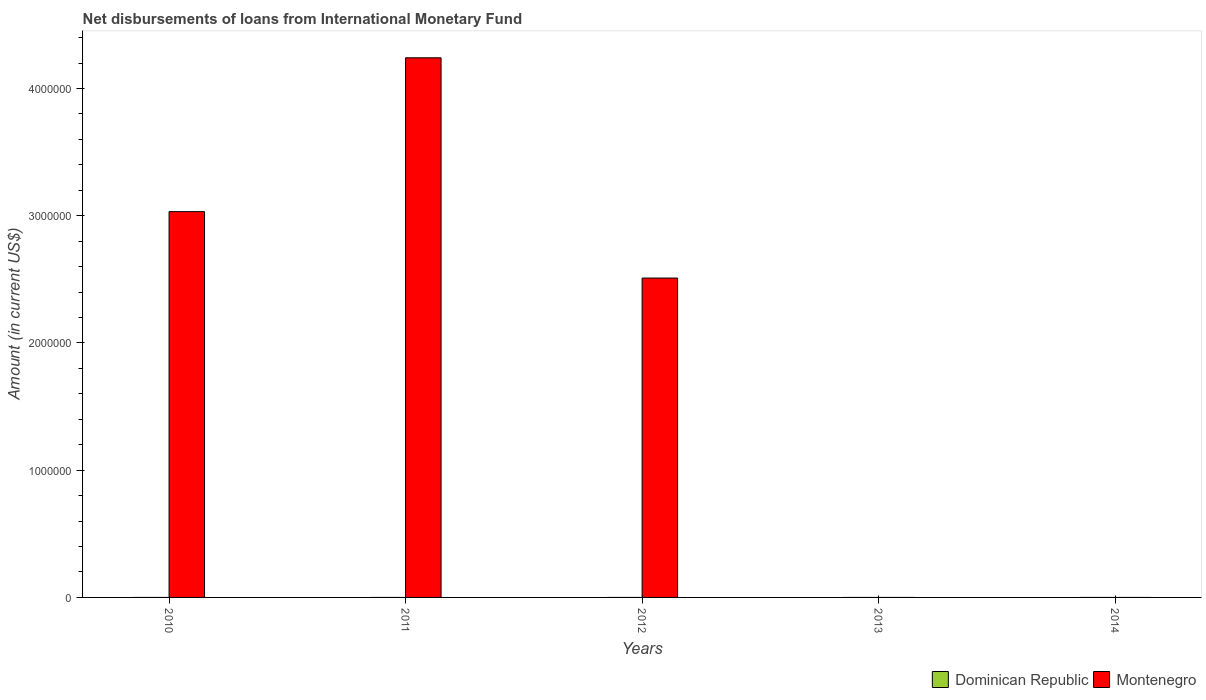Are the number of bars per tick equal to the number of legend labels?
Offer a terse response. No. Are the number of bars on each tick of the X-axis equal?
Your answer should be very brief. No. How many bars are there on the 2nd tick from the left?
Provide a succinct answer. 1. In how many cases, is the number of bars for a given year not equal to the number of legend labels?
Provide a short and direct response. 5. Across all years, what is the maximum amount of loans disbursed in Montenegro?
Make the answer very short. 4.24e+06. Across all years, what is the minimum amount of loans disbursed in Montenegro?
Ensure brevity in your answer.  0. In which year was the amount of loans disbursed in Montenegro maximum?
Your answer should be very brief. 2011. What is the total amount of loans disbursed in Montenegro in the graph?
Your answer should be compact. 9.78e+06. What is the difference between the amount of loans disbursed in Montenegro in 2010 and that in 2012?
Offer a terse response. 5.22e+05. What is the difference between the amount of loans disbursed in Montenegro in 2011 and the amount of loans disbursed in Dominican Republic in 2010?
Ensure brevity in your answer.  4.24e+06. What is the average amount of loans disbursed in Dominican Republic per year?
Make the answer very short. 0. What is the ratio of the amount of loans disbursed in Montenegro in 2010 to that in 2012?
Keep it short and to the point. 1.21. What is the difference between the highest and the second highest amount of loans disbursed in Montenegro?
Offer a terse response. 1.21e+06. What is the difference between the highest and the lowest amount of loans disbursed in Montenegro?
Your response must be concise. 4.24e+06. In how many years, is the amount of loans disbursed in Dominican Republic greater than the average amount of loans disbursed in Dominican Republic taken over all years?
Provide a succinct answer. 0. How many bars are there?
Your answer should be compact. 3. What is the difference between two consecutive major ticks on the Y-axis?
Your answer should be very brief. 1.00e+06. Are the values on the major ticks of Y-axis written in scientific E-notation?
Keep it short and to the point. No. What is the title of the graph?
Keep it short and to the point. Net disbursements of loans from International Monetary Fund. Does "West Bank and Gaza" appear as one of the legend labels in the graph?
Your answer should be very brief. No. What is the Amount (in current US$) in Dominican Republic in 2010?
Provide a succinct answer. 0. What is the Amount (in current US$) in Montenegro in 2010?
Your response must be concise. 3.03e+06. What is the Amount (in current US$) in Montenegro in 2011?
Your response must be concise. 4.24e+06. What is the Amount (in current US$) in Montenegro in 2012?
Your response must be concise. 2.51e+06. What is the Amount (in current US$) in Dominican Republic in 2013?
Your response must be concise. 0. What is the Amount (in current US$) of Montenegro in 2013?
Your answer should be compact. 0. What is the Amount (in current US$) in Dominican Republic in 2014?
Make the answer very short. 0. What is the Amount (in current US$) in Montenegro in 2014?
Your response must be concise. 0. Across all years, what is the maximum Amount (in current US$) of Montenegro?
Keep it short and to the point. 4.24e+06. What is the total Amount (in current US$) of Dominican Republic in the graph?
Your response must be concise. 0. What is the total Amount (in current US$) in Montenegro in the graph?
Offer a very short reply. 9.78e+06. What is the difference between the Amount (in current US$) of Montenegro in 2010 and that in 2011?
Make the answer very short. -1.21e+06. What is the difference between the Amount (in current US$) of Montenegro in 2010 and that in 2012?
Your answer should be very brief. 5.22e+05. What is the difference between the Amount (in current US$) of Montenegro in 2011 and that in 2012?
Your answer should be compact. 1.73e+06. What is the average Amount (in current US$) of Dominican Republic per year?
Offer a very short reply. 0. What is the average Amount (in current US$) in Montenegro per year?
Give a very brief answer. 1.96e+06. What is the ratio of the Amount (in current US$) in Montenegro in 2010 to that in 2011?
Keep it short and to the point. 0.71. What is the ratio of the Amount (in current US$) in Montenegro in 2010 to that in 2012?
Your answer should be very brief. 1.21. What is the ratio of the Amount (in current US$) in Montenegro in 2011 to that in 2012?
Your answer should be very brief. 1.69. What is the difference between the highest and the second highest Amount (in current US$) of Montenegro?
Keep it short and to the point. 1.21e+06. What is the difference between the highest and the lowest Amount (in current US$) of Montenegro?
Offer a very short reply. 4.24e+06. 